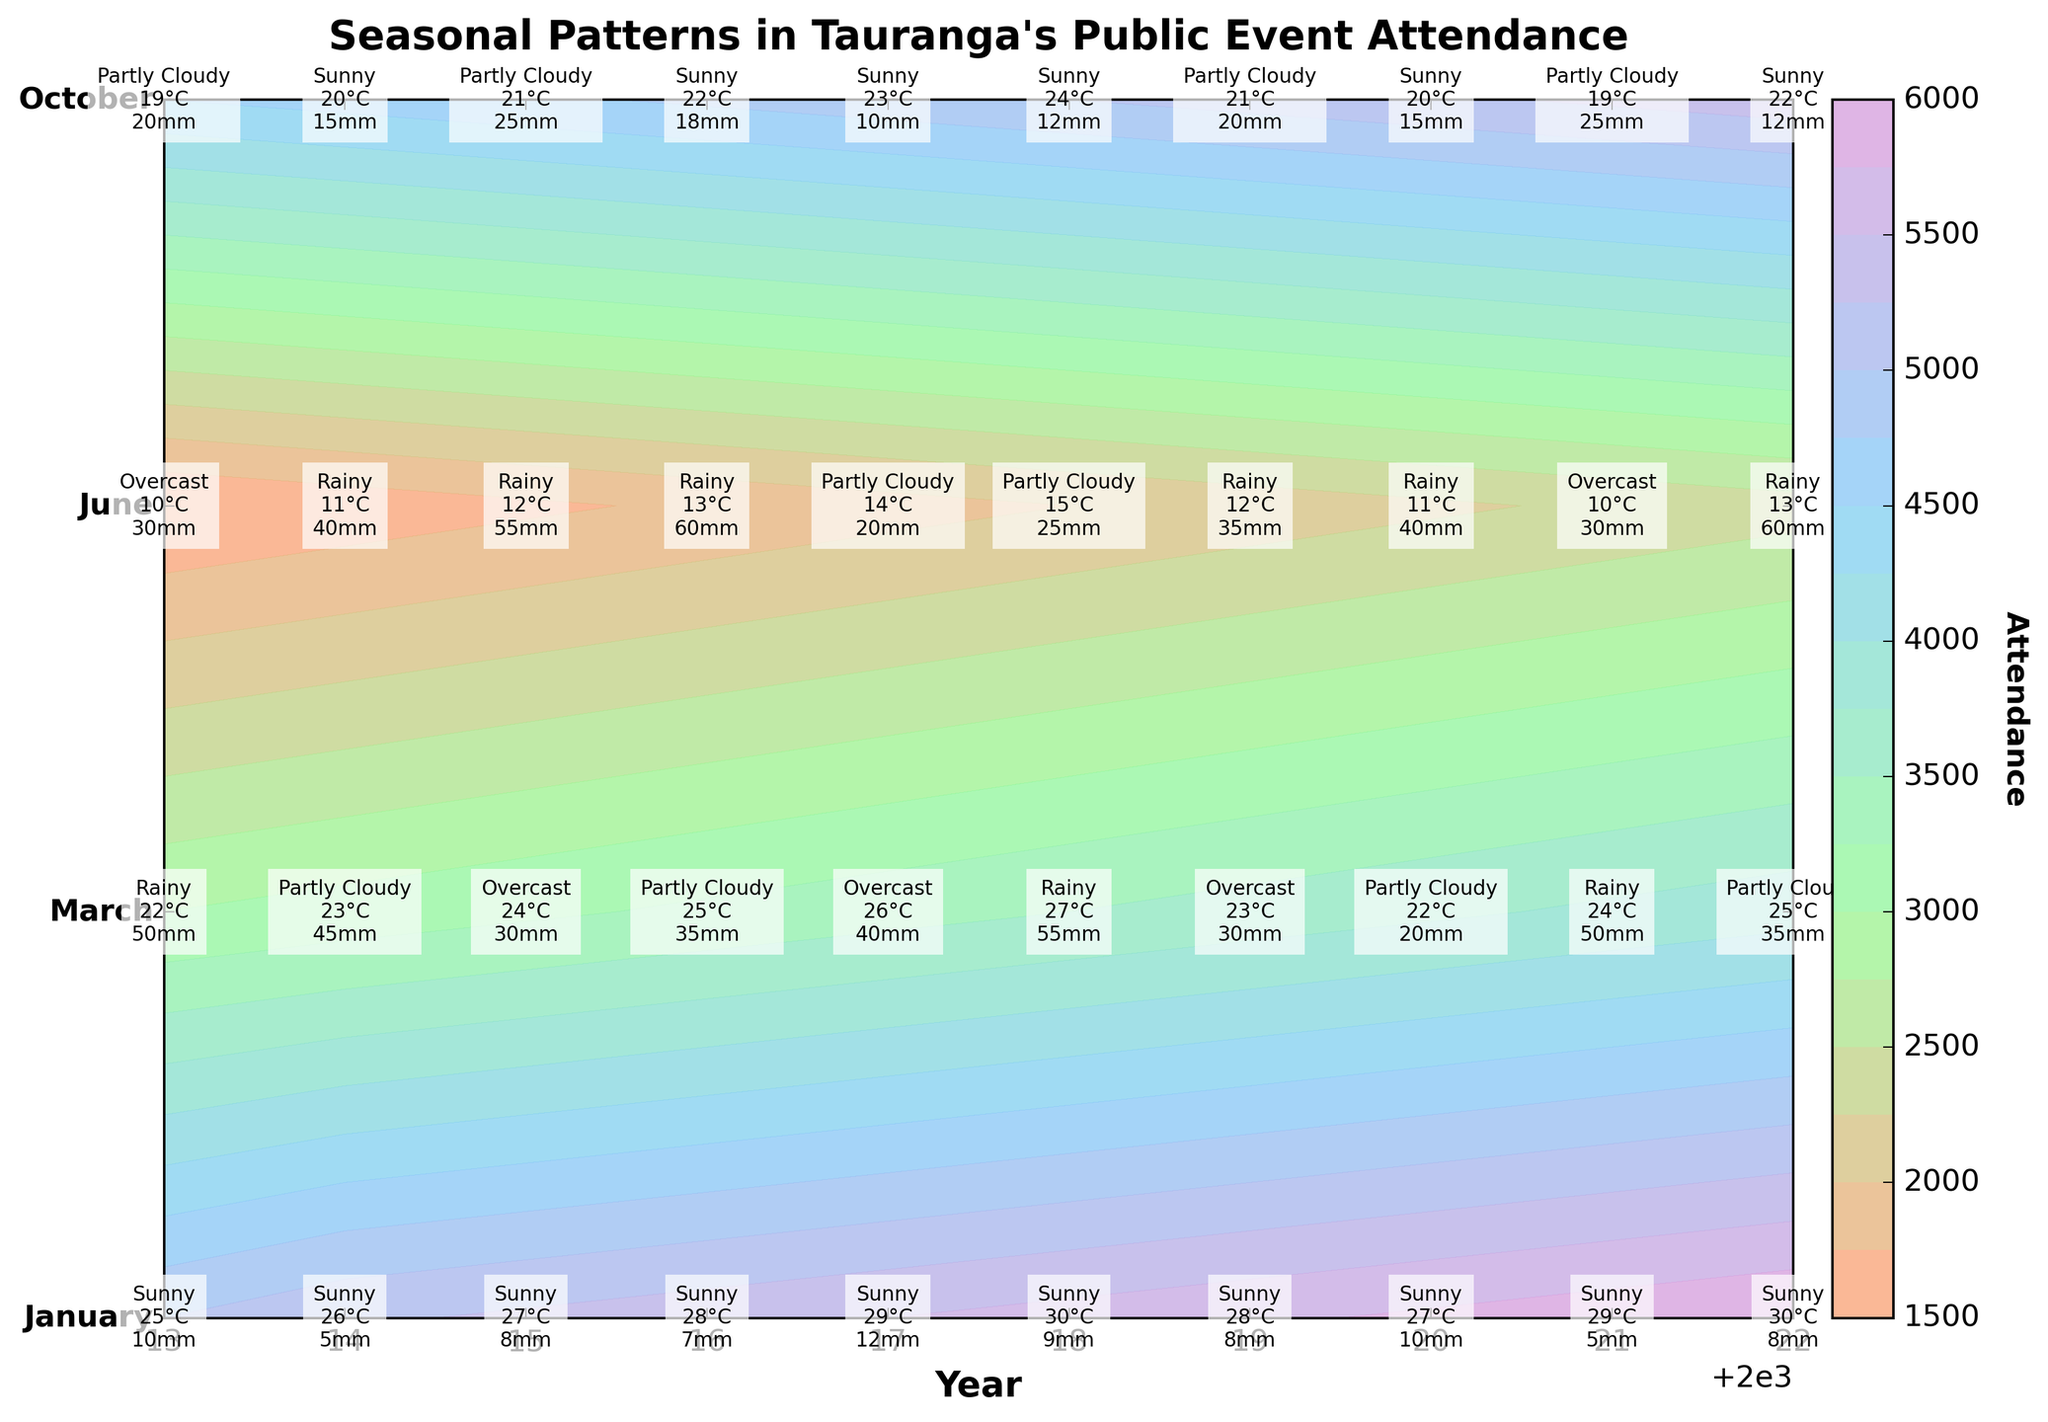What's the title of the figure? The title is typically found at the top of the figure, it describes the overall subject of the plot. In this case, it is centered at the top.
Answer: Seasonal Patterns in Tauranga's Public Event Attendance What do the colors in the contour plot represent? The contour plot uses varying colors to represent different levels or ranges of attendance. Generally, warmer colors (like shades of red or orange) indicate higher attendance, while cooler colors (like shades of blue or green) indicate lower attendance.
Answer: Levels of attendance Which event in January typically has the highest attendance? By looking at the January row in each year, we can see that the Tauranga Arts Festival has consistently high attendance compared to other events.
Answer: Tauranga Arts Festival What's the weather condition during the Tauranga Arts Festival in January 2018? Find the text annotation corresponding to the Tauranga Arts Festival in January 2018. The weather condition is indicated beside other weather details.
Answer: Sunny How does the attendance for June events change from 2013 to 2022? To analyze the change, observe the contour line along the June axis from 2013 to 2022 and note the color transitions representing changes in attendance levels. Attendance gradually increases from 2013 to 2022.
Answer: Gradual increase Which year has the lowest total rainfall during the National Jazz Festival in March? Identify the text annotations for the National Jazz Festival in March across different years and compare the total rainfall values. The year with the lowest value is the answer.
Answer: 2020 Compare the average temperature during the Taurus Garden & Art Festival in October 2013 and October 2018. Which one is higher? Look at the text annotations for the Taurus Garden & Art Festival in the given years and compare the average temperature values.
Answer: October 2018 Which month generally shows the highest attendance across all years? Observing the contour plot, January has the most consistently high colors indicating higher levels of attendance across different years compared to other months.
Answer: January What's the difference in attendance for the Winter Solstice Celebration between 2013 and 2022? Locate the attendance values for the Winter Solstice Celebration in 2013 and 2022, then subtract the former value from the latter.
Answer: 900 How many events have 'Sunny' weather condition in 2022? Find the text annotations for all events in 2022 and count those with 'Sunny' as the weather condition. There are January and October events with 'Sunny' weather conditions in 2022.
Answer: 2 